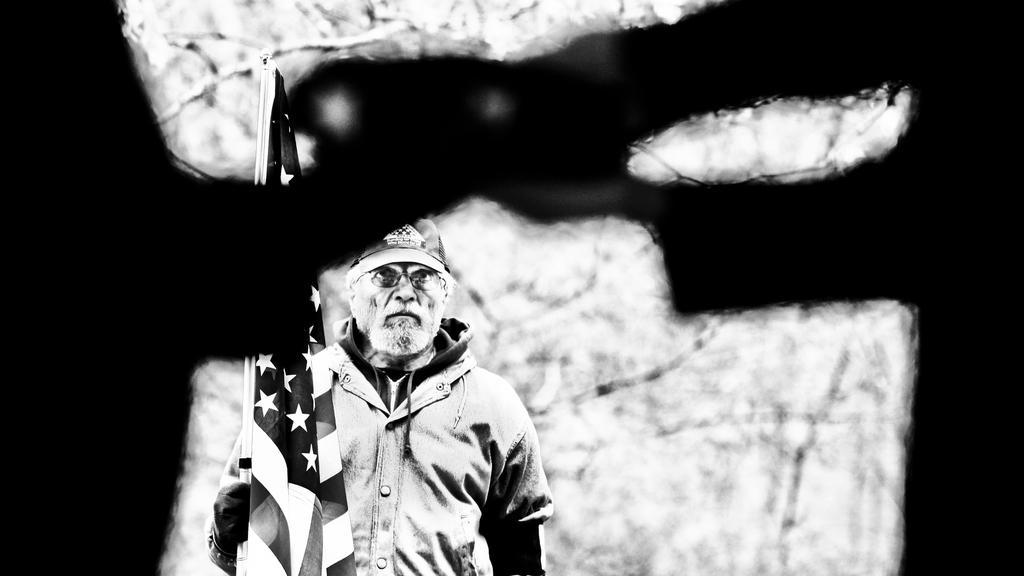How would you summarize this image in a sentence or two? It is a black and white picture. In this image we can see a person and flag. Person wore a jacket and cap. In the background of the image it is blurry. 